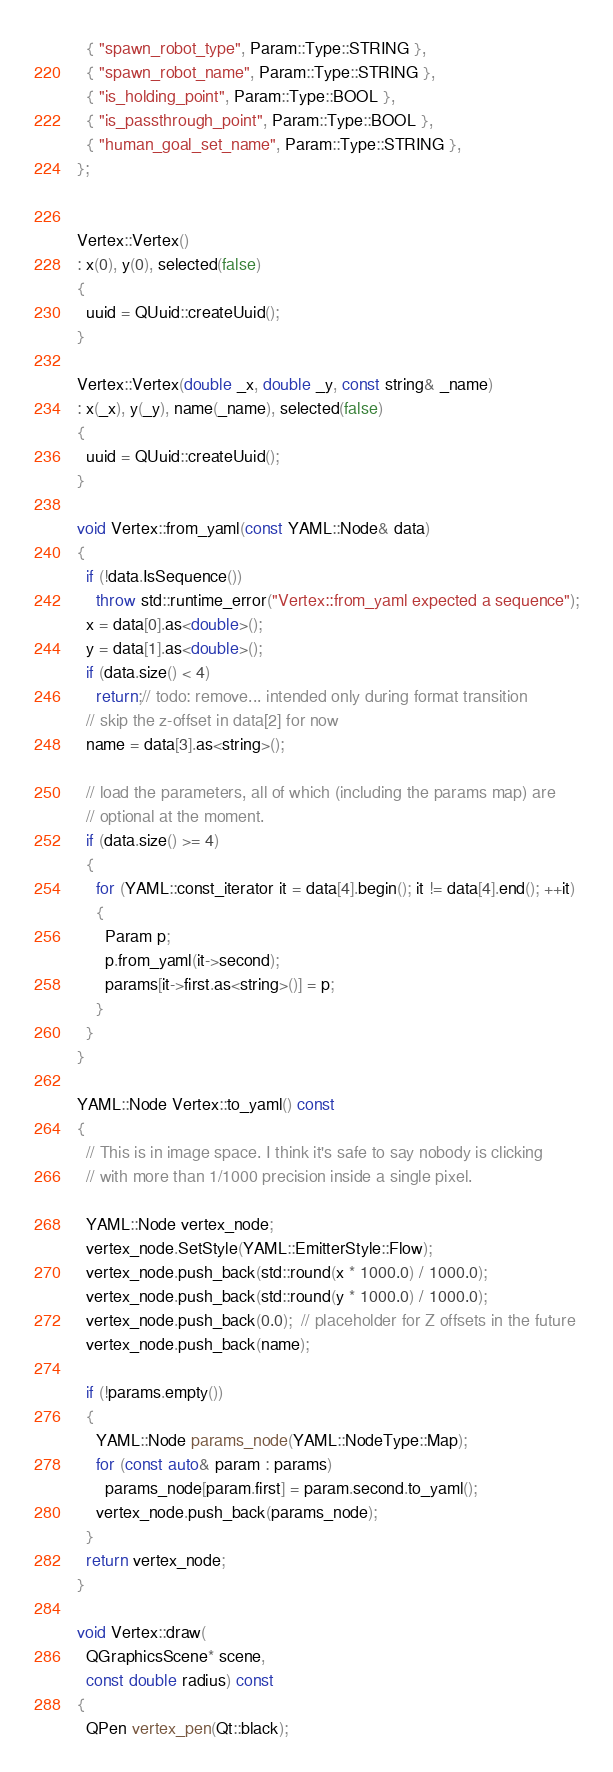Convert code to text. <code><loc_0><loc_0><loc_500><loc_500><_C++_>  { "spawn_robot_type", Param::Type::STRING },
  { "spawn_robot_name", Param::Type::STRING },
  { "is_holding_point", Param::Type::BOOL },
  { "is_passthrough_point", Param::Type::BOOL },
  { "human_goal_set_name", Param::Type::STRING },
};


Vertex::Vertex()
: x(0), y(0), selected(false)
{
  uuid = QUuid::createUuid();
}

Vertex::Vertex(double _x, double _y, const string& _name)
: x(_x), y(_y), name(_name), selected(false)
{
  uuid = QUuid::createUuid();
}

void Vertex::from_yaml(const YAML::Node& data)
{
  if (!data.IsSequence())
    throw std::runtime_error("Vertex::from_yaml expected a sequence");
  x = data[0].as<double>();
  y = data[1].as<double>();
  if (data.size() < 4)
    return;// todo: remove... intended only during format transition
  // skip the z-offset in data[2] for now
  name = data[3].as<string>();

  // load the parameters, all of which (including the params map) are
  // optional at the moment.
  if (data.size() >= 4)
  {
    for (YAML::const_iterator it = data[4].begin(); it != data[4].end(); ++it)
    {
      Param p;
      p.from_yaml(it->second);
      params[it->first.as<string>()] = p;
    }
  }
}

YAML::Node Vertex::to_yaml() const
{
  // This is in image space. I think it's safe to say nobody is clicking
  // with more than 1/1000 precision inside a single pixel.

  YAML::Node vertex_node;
  vertex_node.SetStyle(YAML::EmitterStyle::Flow);
  vertex_node.push_back(std::round(x * 1000.0) / 1000.0);
  vertex_node.push_back(std::round(y * 1000.0) / 1000.0);
  vertex_node.push_back(0.0);  // placeholder for Z offsets in the future
  vertex_node.push_back(name);

  if (!params.empty())
  {
    YAML::Node params_node(YAML::NodeType::Map);
    for (const auto& param : params)
      params_node[param.first] = param.second.to_yaml();
    vertex_node.push_back(params_node);
  }
  return vertex_node;
}

void Vertex::draw(
  QGraphicsScene* scene,
  const double radius) const
{
  QPen vertex_pen(Qt::black);</code> 